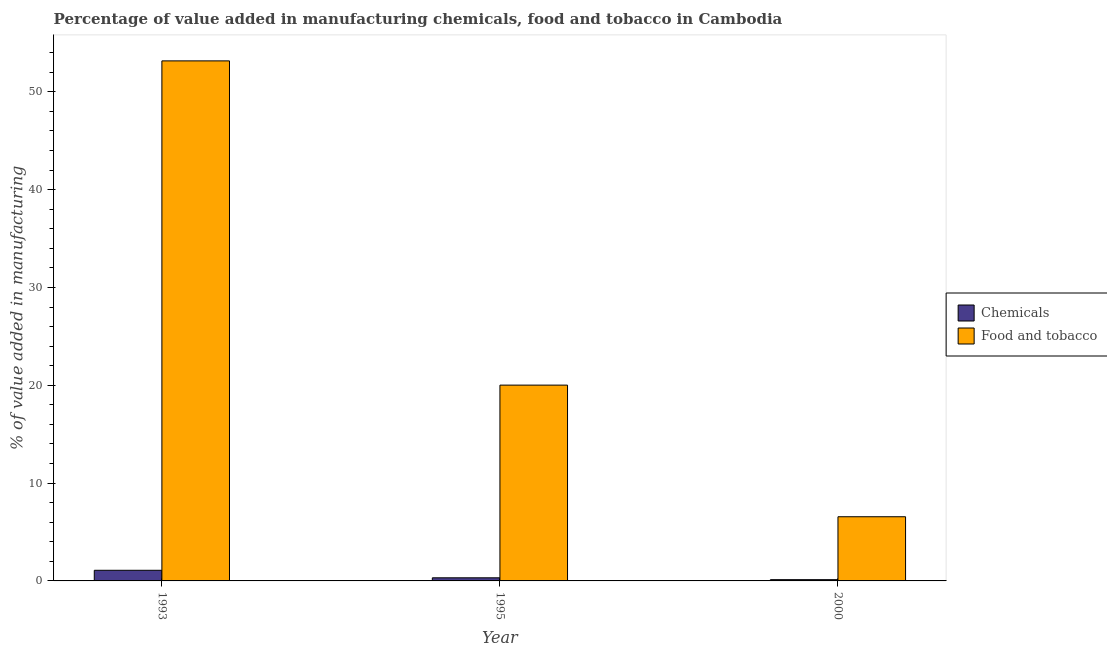Are the number of bars per tick equal to the number of legend labels?
Your answer should be very brief. Yes. Are the number of bars on each tick of the X-axis equal?
Make the answer very short. Yes. How many bars are there on the 3rd tick from the left?
Offer a terse response. 2. How many bars are there on the 2nd tick from the right?
Your answer should be very brief. 2. What is the value added by manufacturing food and tobacco in 1995?
Provide a succinct answer. 20.02. Across all years, what is the maximum value added by  manufacturing chemicals?
Keep it short and to the point. 1.09. Across all years, what is the minimum value added by manufacturing food and tobacco?
Ensure brevity in your answer.  6.56. In which year was the value added by manufacturing food and tobacco maximum?
Ensure brevity in your answer.  1993. What is the total value added by  manufacturing chemicals in the graph?
Your response must be concise. 1.53. What is the difference between the value added by  manufacturing chemicals in 1995 and that in 2000?
Your response must be concise. 0.19. What is the difference between the value added by  manufacturing chemicals in 1993 and the value added by manufacturing food and tobacco in 1995?
Your answer should be compact. 0.77. What is the average value added by  manufacturing chemicals per year?
Provide a short and direct response. 0.51. In the year 2000, what is the difference between the value added by  manufacturing chemicals and value added by manufacturing food and tobacco?
Give a very brief answer. 0. In how many years, is the value added by  manufacturing chemicals greater than 42 %?
Keep it short and to the point. 0. What is the ratio of the value added by  manufacturing chemicals in 1993 to that in 2000?
Keep it short and to the point. 8.49. Is the value added by  manufacturing chemicals in 1993 less than that in 2000?
Provide a short and direct response. No. What is the difference between the highest and the second highest value added by manufacturing food and tobacco?
Ensure brevity in your answer.  33.15. What is the difference between the highest and the lowest value added by  manufacturing chemicals?
Offer a very short reply. 0.96. In how many years, is the value added by manufacturing food and tobacco greater than the average value added by manufacturing food and tobacco taken over all years?
Your answer should be very brief. 1. What does the 1st bar from the left in 1995 represents?
Provide a succinct answer. Chemicals. What does the 1st bar from the right in 1993 represents?
Offer a very short reply. Food and tobacco. What is the difference between two consecutive major ticks on the Y-axis?
Keep it short and to the point. 10. Are the values on the major ticks of Y-axis written in scientific E-notation?
Offer a terse response. No. Does the graph contain grids?
Keep it short and to the point. No. How are the legend labels stacked?
Your response must be concise. Vertical. What is the title of the graph?
Make the answer very short. Percentage of value added in manufacturing chemicals, food and tobacco in Cambodia. What is the label or title of the Y-axis?
Offer a terse response. % of value added in manufacturing. What is the % of value added in manufacturing of Chemicals in 1993?
Your response must be concise. 1.09. What is the % of value added in manufacturing in Food and tobacco in 1993?
Offer a terse response. 53.17. What is the % of value added in manufacturing in Chemicals in 1995?
Make the answer very short. 0.32. What is the % of value added in manufacturing in Food and tobacco in 1995?
Keep it short and to the point. 20.02. What is the % of value added in manufacturing in Chemicals in 2000?
Provide a succinct answer. 0.13. What is the % of value added in manufacturing in Food and tobacco in 2000?
Give a very brief answer. 6.56. Across all years, what is the maximum % of value added in manufacturing of Chemicals?
Give a very brief answer. 1.09. Across all years, what is the maximum % of value added in manufacturing in Food and tobacco?
Give a very brief answer. 53.17. Across all years, what is the minimum % of value added in manufacturing of Chemicals?
Keep it short and to the point. 0.13. Across all years, what is the minimum % of value added in manufacturing of Food and tobacco?
Provide a succinct answer. 6.56. What is the total % of value added in manufacturing of Chemicals in the graph?
Your answer should be very brief. 1.53. What is the total % of value added in manufacturing in Food and tobacco in the graph?
Make the answer very short. 79.75. What is the difference between the % of value added in manufacturing of Chemicals in 1993 and that in 1995?
Your answer should be compact. 0.77. What is the difference between the % of value added in manufacturing in Food and tobacco in 1993 and that in 1995?
Ensure brevity in your answer.  33.15. What is the difference between the % of value added in manufacturing of Food and tobacco in 1993 and that in 2000?
Your answer should be compact. 46.61. What is the difference between the % of value added in manufacturing of Chemicals in 1995 and that in 2000?
Your response must be concise. 0.19. What is the difference between the % of value added in manufacturing of Food and tobacco in 1995 and that in 2000?
Offer a terse response. 13.46. What is the difference between the % of value added in manufacturing in Chemicals in 1993 and the % of value added in manufacturing in Food and tobacco in 1995?
Provide a short and direct response. -18.93. What is the difference between the % of value added in manufacturing of Chemicals in 1993 and the % of value added in manufacturing of Food and tobacco in 2000?
Make the answer very short. -5.47. What is the difference between the % of value added in manufacturing of Chemicals in 1995 and the % of value added in manufacturing of Food and tobacco in 2000?
Give a very brief answer. -6.24. What is the average % of value added in manufacturing of Chemicals per year?
Keep it short and to the point. 0.51. What is the average % of value added in manufacturing of Food and tobacco per year?
Keep it short and to the point. 26.58. In the year 1993, what is the difference between the % of value added in manufacturing in Chemicals and % of value added in manufacturing in Food and tobacco?
Ensure brevity in your answer.  -52.08. In the year 1995, what is the difference between the % of value added in manufacturing of Chemicals and % of value added in manufacturing of Food and tobacco?
Offer a very short reply. -19.7. In the year 2000, what is the difference between the % of value added in manufacturing of Chemicals and % of value added in manufacturing of Food and tobacco?
Provide a short and direct response. -6.43. What is the ratio of the % of value added in manufacturing of Chemicals in 1993 to that in 1995?
Offer a terse response. 3.42. What is the ratio of the % of value added in manufacturing of Food and tobacco in 1993 to that in 1995?
Ensure brevity in your answer.  2.66. What is the ratio of the % of value added in manufacturing of Chemicals in 1993 to that in 2000?
Ensure brevity in your answer.  8.49. What is the ratio of the % of value added in manufacturing in Food and tobacco in 1993 to that in 2000?
Your answer should be very brief. 8.1. What is the ratio of the % of value added in manufacturing in Chemicals in 1995 to that in 2000?
Provide a succinct answer. 2.48. What is the ratio of the % of value added in manufacturing in Food and tobacco in 1995 to that in 2000?
Provide a short and direct response. 3.05. What is the difference between the highest and the second highest % of value added in manufacturing in Chemicals?
Offer a very short reply. 0.77. What is the difference between the highest and the second highest % of value added in manufacturing in Food and tobacco?
Offer a very short reply. 33.15. What is the difference between the highest and the lowest % of value added in manufacturing of Food and tobacco?
Your answer should be compact. 46.61. 